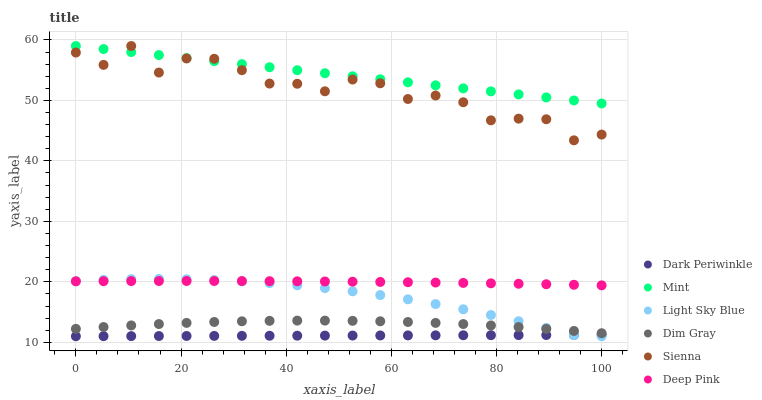Does Dark Periwinkle have the minimum area under the curve?
Answer yes or no. Yes. Does Mint have the maximum area under the curve?
Answer yes or no. Yes. Does Deep Pink have the minimum area under the curve?
Answer yes or no. No. Does Deep Pink have the maximum area under the curve?
Answer yes or no. No. Is Dark Periwinkle the smoothest?
Answer yes or no. Yes. Is Sienna the roughest?
Answer yes or no. Yes. Is Deep Pink the smoothest?
Answer yes or no. No. Is Deep Pink the roughest?
Answer yes or no. No. Does Light Sky Blue have the lowest value?
Answer yes or no. Yes. Does Deep Pink have the lowest value?
Answer yes or no. No. Does Mint have the highest value?
Answer yes or no. Yes. Does Deep Pink have the highest value?
Answer yes or no. No. Is Dim Gray less than Sienna?
Answer yes or no. Yes. Is Sienna greater than Dark Periwinkle?
Answer yes or no. Yes. Does Mint intersect Sienna?
Answer yes or no. Yes. Is Mint less than Sienna?
Answer yes or no. No. Is Mint greater than Sienna?
Answer yes or no. No. Does Dim Gray intersect Sienna?
Answer yes or no. No. 